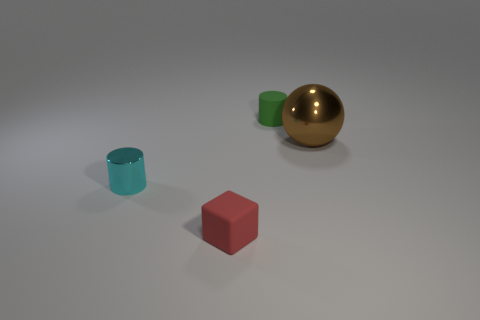Can you tell me the colors of the objects in the image? Certainly! The image features objects of various colors: a tiny cyan cylinder, a red cube, a green cylinder which is larger than the cyan one, and a metallic object that appears to be a gold or brass-colored sphere. 